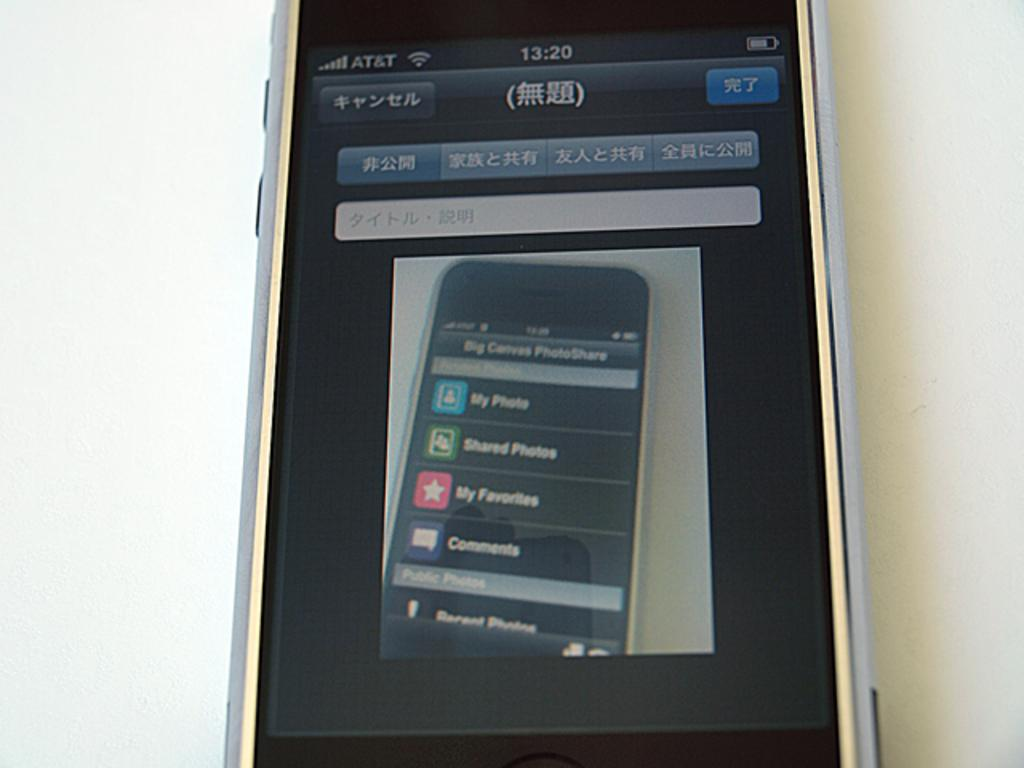<image>
Write a terse but informative summary of the picture. An AT&T device showing a picture of another device on its screen. 